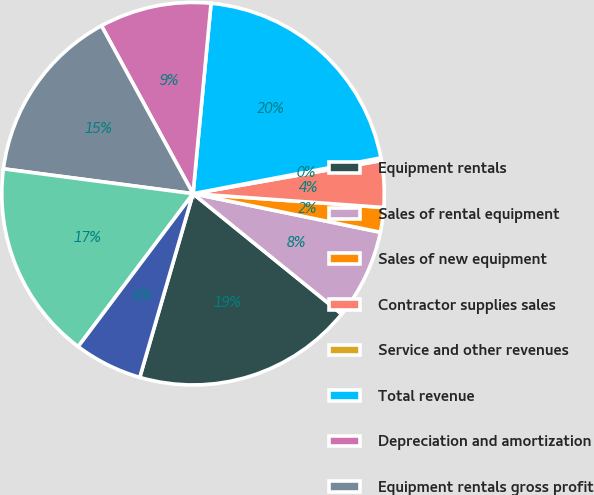Convert chart to OTSL. <chart><loc_0><loc_0><loc_500><loc_500><pie_chart><fcel>Equipment rentals<fcel>Sales of rental equipment<fcel>Sales of new equipment<fcel>Contractor supplies sales<fcel>Service and other revenues<fcel>Total revenue<fcel>Depreciation and amortization<fcel>Equipment rentals gross profit<fcel>2012<fcel>Equipment rentals Sales of<nl><fcel>18.66%<fcel>7.6%<fcel>2.08%<fcel>3.92%<fcel>0.23%<fcel>20.5%<fcel>9.45%<fcel>14.98%<fcel>16.82%<fcel>5.76%<nl></chart> 